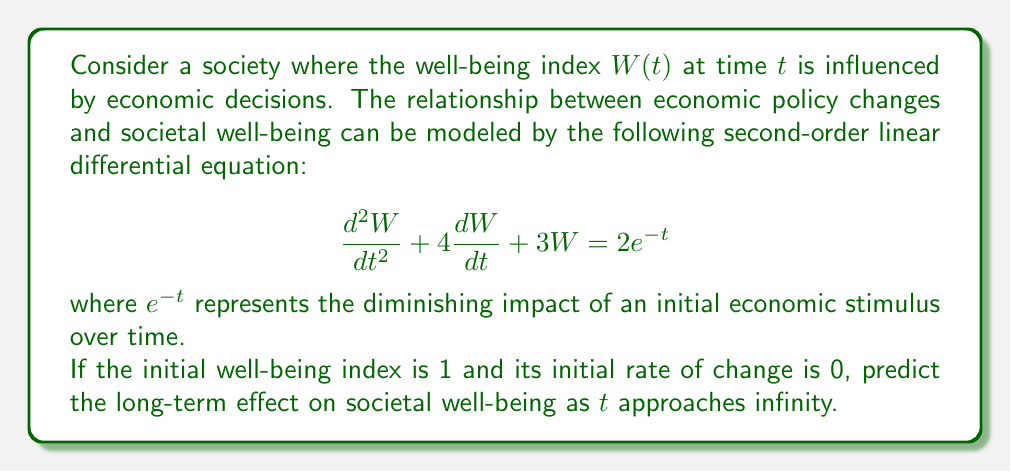Provide a solution to this math problem. To solve this problem, we'll follow these steps:

1) First, we need to find the general solution to the homogeneous equation:

   $$\frac{d^2W}{dt^2} + 4\frac{dW}{dt} + 3W = 0$$

   The characteristic equation is $r^2 + 4r + 3 = 0$
   Solving this, we get $r = -1$ or $r = -3$
   So, the homogeneous solution is $W_h = c_1e^{-t} + c_2e^{-3t}$

2) Next, we need to find a particular solution. Given the right side of the equation, we can guess a solution of the form $W_p = Ae^{-t}$

   Substituting this into the original equation:
   $$A(-1)^2e^{-t} + 4A(-1)e^{-t} + 3Ae^{-t} = 2e^{-t}$$
   $$Ae^{-t} - 4Ae^{-t} + 3Ae^{-t} = 2e^{-t}$$
   $$0 = 2e^{-t}$$
   $$A = 1$$

   So, $W_p = e^{-t}$

3) The general solution is $W = W_h + W_p = c_1e^{-t} + c_2e^{-3t} + e^{-t}$

4) Using the initial conditions:
   At $t = 0$, $W = 1$, so $c_1 + c_2 + 1 = 1$, therefore $c_1 + c_2 = 0$
   
   At $t = 0$, $\frac{dW}{dt} = 0$, so $-c_1 - 3c_2 - 1 = 0$

5) Solving these equations:
   $c_1 + c_2 = 0$
   $-c_1 - 3c_2 = 1$
   
   Subtracting the first equation from the second:
   $-2c_2 = 1$
   $c_2 = -\frac{1}{2}$
   $c_1 = \frac{1}{2}$

6) Therefore, the complete solution is:

   $$W = \frac{1}{2}e^{-t} - \frac{1}{2}e^{-3t} + e^{-t}$$

7) As $t$ approaches infinity, both $e^{-t}$ and $e^{-3t}$ approach 0.
Answer: As $t$ approaches infinity, $W$ approaches 0. This suggests that the long-term effect of the initial economic stimulus on societal well-being diminishes over time, eventually returning to a baseline state. 